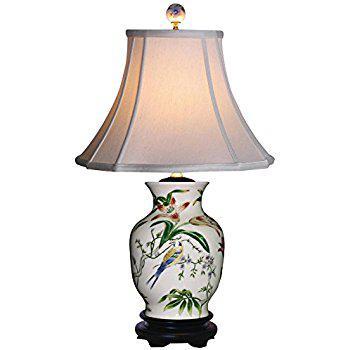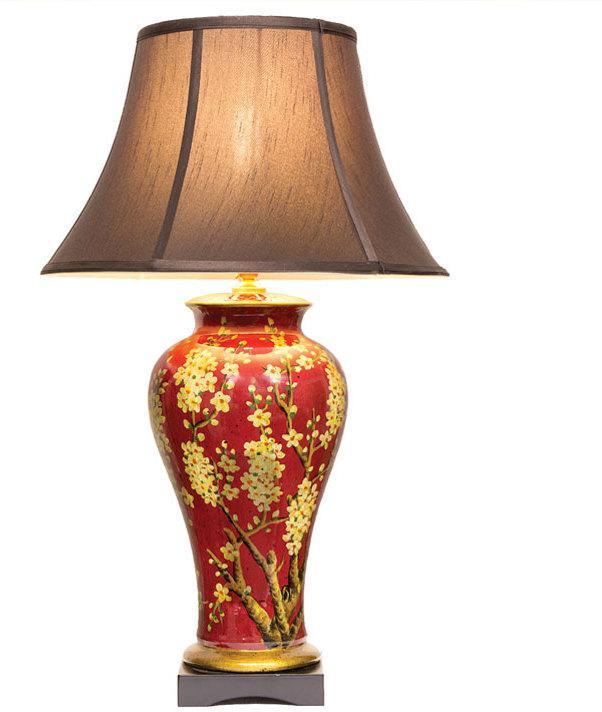The first image is the image on the left, the second image is the image on the right. Considering the images on both sides, is "In at least one image there is a  white porcelain lamp with two birds facing each other  etched in to the base." valid? Answer yes or no. No. The first image is the image on the left, the second image is the image on the right. Considering the images on both sides, is "The ceramic base of the lamp on the right has a fuller top and tapers toward the bottom, and the base of the lamp on the left is decorated with a bird and flowers and has a dark footed bottom." valid? Answer yes or no. Yes. 